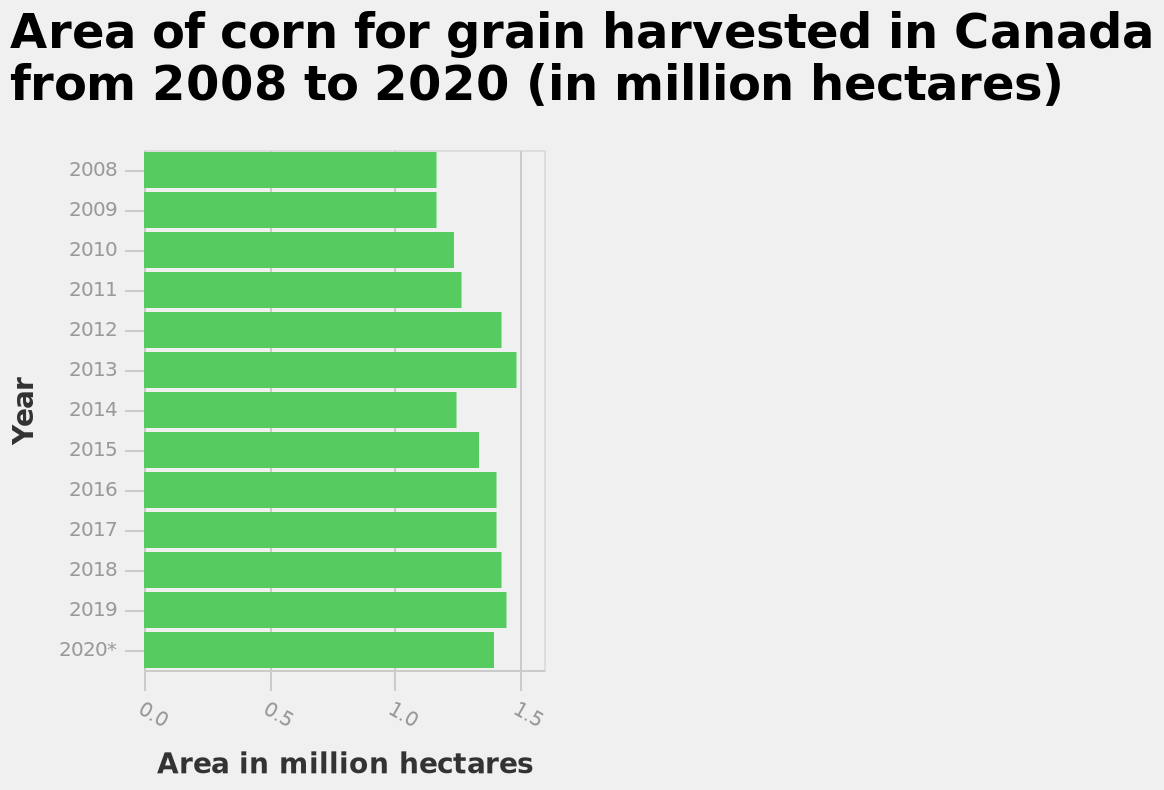<image>
Offer a thorough analysis of the image. The rate of harvest is very similar most years apart from 2012 and 2013 where it is much higher. What is the title of the bar chart?  The title of the bar chart is "Area of corn for grain harvested in Canada from 2008 to 2020 (in million hectares)". 